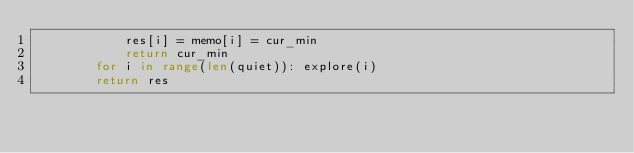<code> <loc_0><loc_0><loc_500><loc_500><_Python_>            res[i] = memo[i] = cur_min
            return cur_min
        for i in range(len(quiet)): explore(i)
        return res</code> 